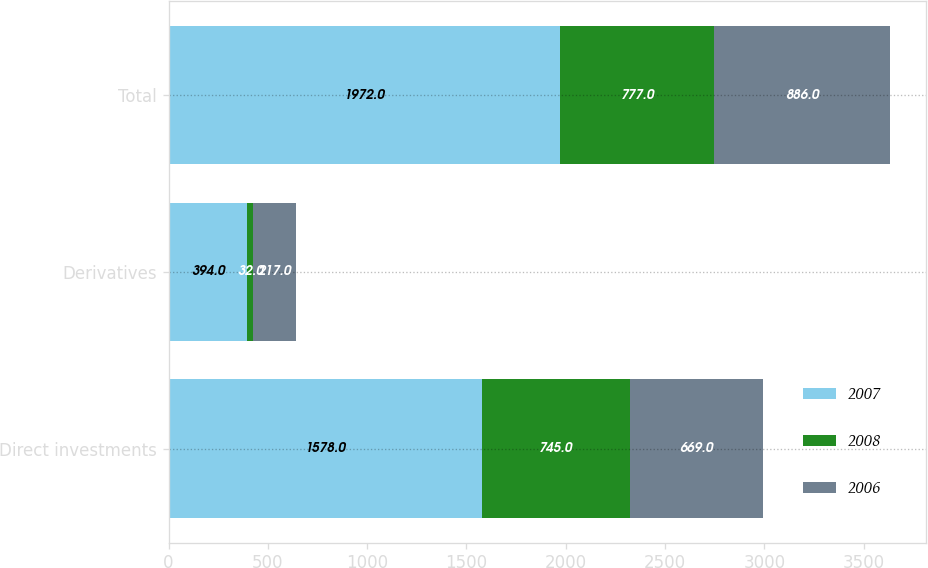Convert chart. <chart><loc_0><loc_0><loc_500><loc_500><stacked_bar_chart><ecel><fcel>Direct investments<fcel>Derivatives<fcel>Total<nl><fcel>2007<fcel>1578<fcel>394<fcel>1972<nl><fcel>2008<fcel>745<fcel>32<fcel>777<nl><fcel>2006<fcel>669<fcel>217<fcel>886<nl></chart> 